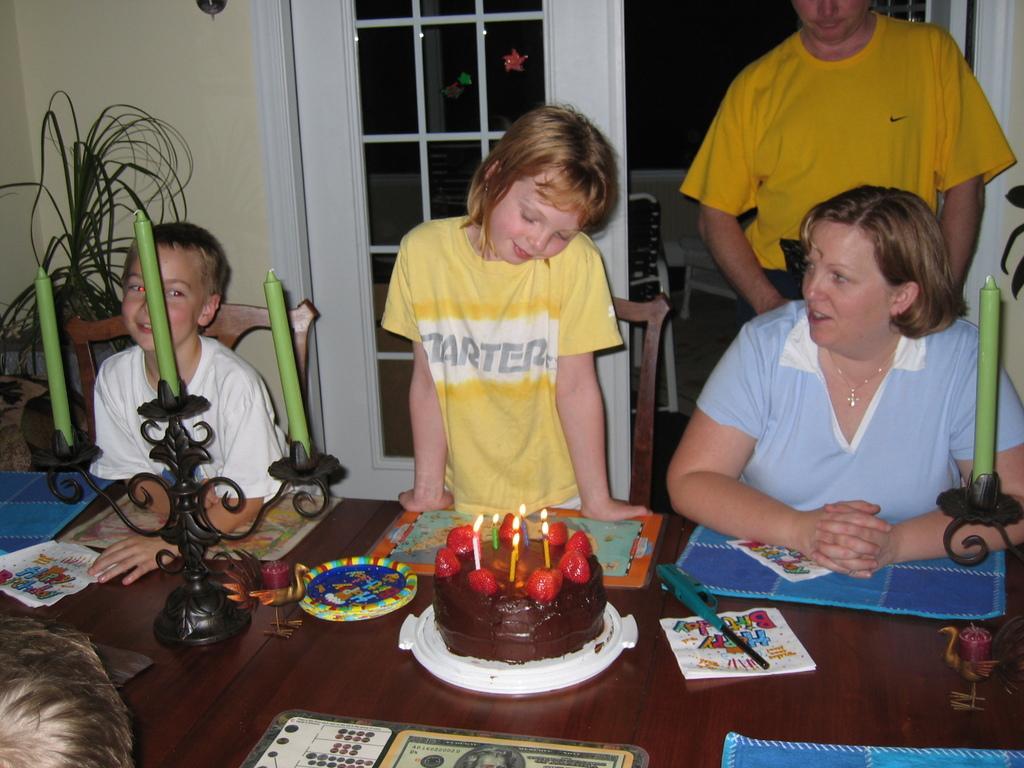Can you describe this image briefly? In this picture there is a boy and a woman sitting on the chair. There is a girl and a person standing. There is a cake, strawberry, candles on the plate. There is a paper, blue cloth, peacock idol, green candles and few objects on the table. There is a plant at the corner. There is a person and a picture. 